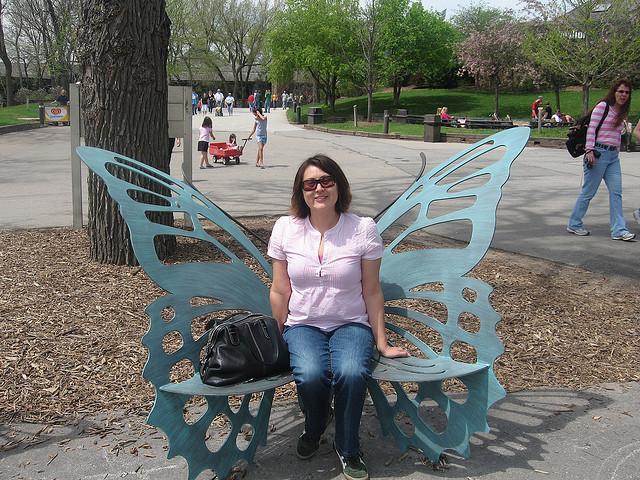How many people are in the picture?
Give a very brief answer. 3. 